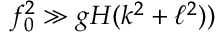<formula> <loc_0><loc_0><loc_500><loc_500>f _ { 0 } ^ { 2 } \gg g H ( k ^ { 2 } + \ell ^ { 2 } ) )</formula> 